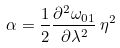Convert formula to latex. <formula><loc_0><loc_0><loc_500><loc_500>\alpha = \frac { 1 } { 2 } \frac { \partial ^ { 2 } \omega _ { 0 1 } } { \partial \lambda ^ { 2 } } \, \eta ^ { 2 }</formula> 